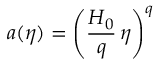<formula> <loc_0><loc_0><loc_500><loc_500>a ( \eta ) = \left ( \frac { H _ { 0 } } { q } \, \eta \right ) ^ { q }</formula> 